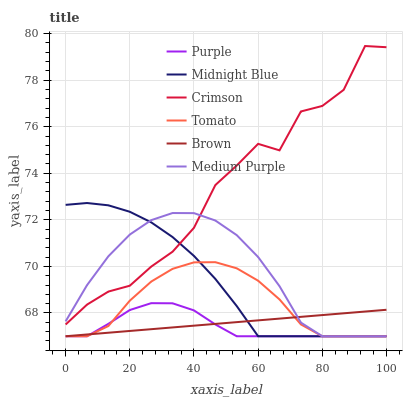Does Purple have the minimum area under the curve?
Answer yes or no. Yes. Does Crimson have the maximum area under the curve?
Answer yes or no. Yes. Does Brown have the minimum area under the curve?
Answer yes or no. No. Does Brown have the maximum area under the curve?
Answer yes or no. No. Is Brown the smoothest?
Answer yes or no. Yes. Is Crimson the roughest?
Answer yes or no. Yes. Is Midnight Blue the smoothest?
Answer yes or no. No. Is Midnight Blue the roughest?
Answer yes or no. No. Does Tomato have the lowest value?
Answer yes or no. Yes. Does Crimson have the lowest value?
Answer yes or no. No. Does Crimson have the highest value?
Answer yes or no. Yes. Does Midnight Blue have the highest value?
Answer yes or no. No. Is Tomato less than Crimson?
Answer yes or no. Yes. Is Crimson greater than Tomato?
Answer yes or no. Yes. Does Brown intersect Medium Purple?
Answer yes or no. Yes. Is Brown less than Medium Purple?
Answer yes or no. No. Is Brown greater than Medium Purple?
Answer yes or no. No. Does Tomato intersect Crimson?
Answer yes or no. No. 